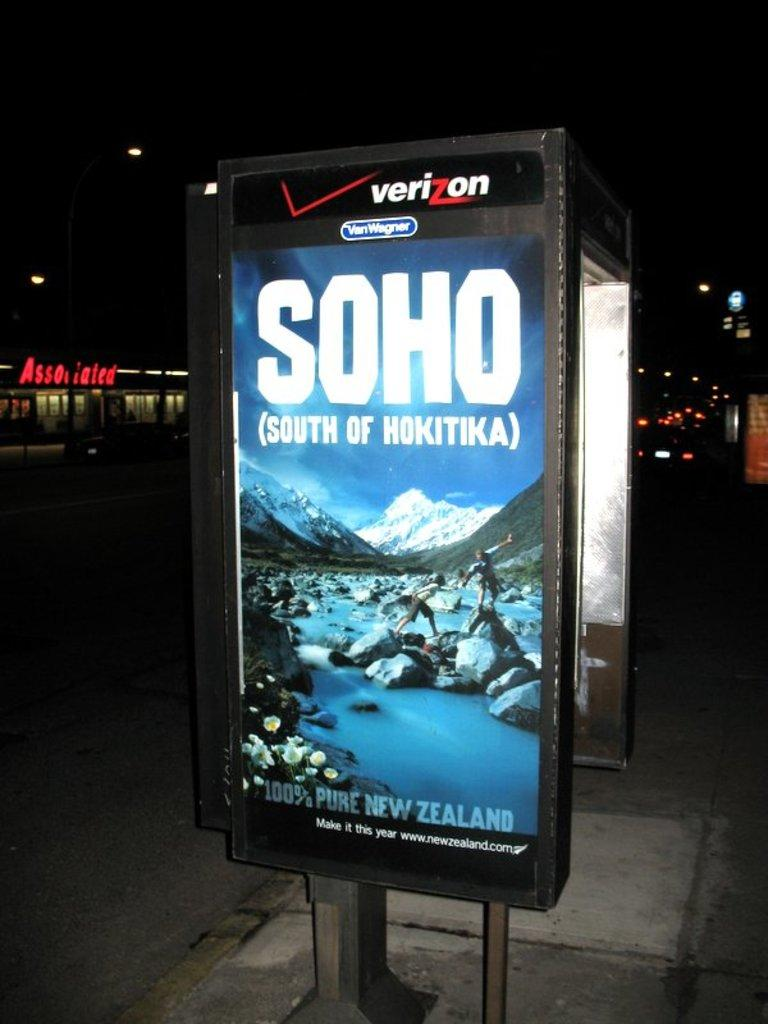<image>
Render a clear and concise summary of the photo. A Verizon outdoor advertisement for Soho (South of Hokitika). 